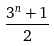Convert formula to latex. <formula><loc_0><loc_0><loc_500><loc_500>\frac { 3 ^ { n } + 1 } { 2 }</formula> 